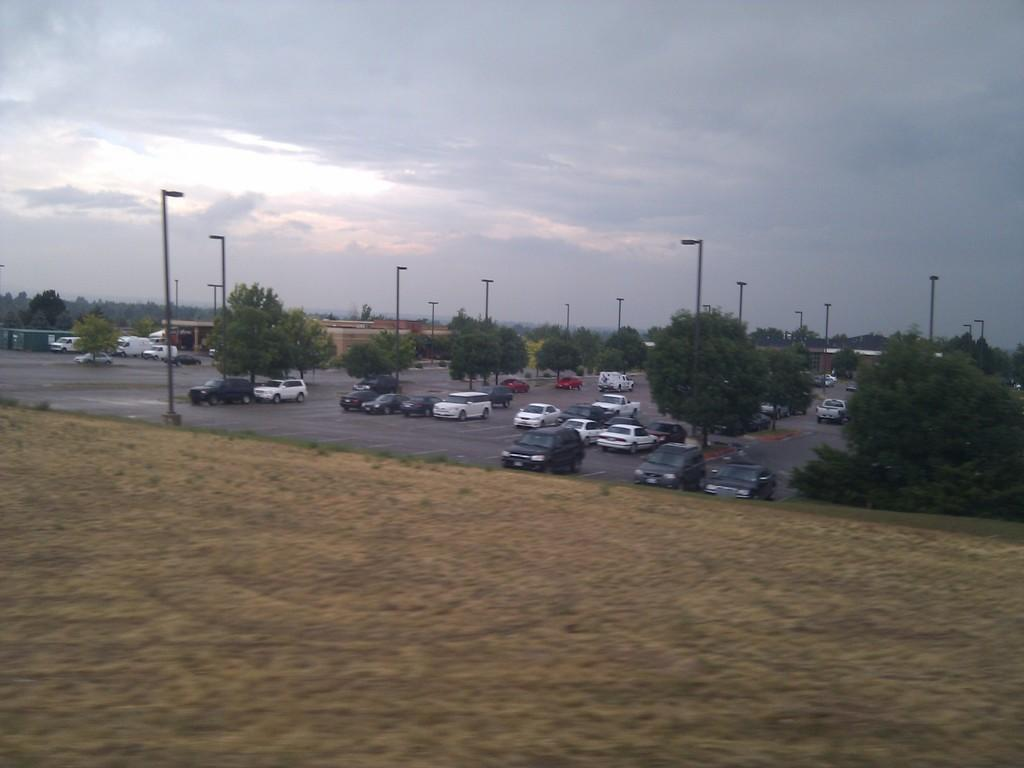What is the main subject of the image? The main subject of the image is a road. What can be seen on the road in the image? There are many vehicles on the road in the image. What type of vegetation is visible in the image? Grass, trees, and a pole are present in the image. What is the condition of the sky in the image? The sky is cloudy in the image. Who is the owner of the afterthought in the image? There is no mention of an afterthought in the image, so it is not possible to determine an owner. 